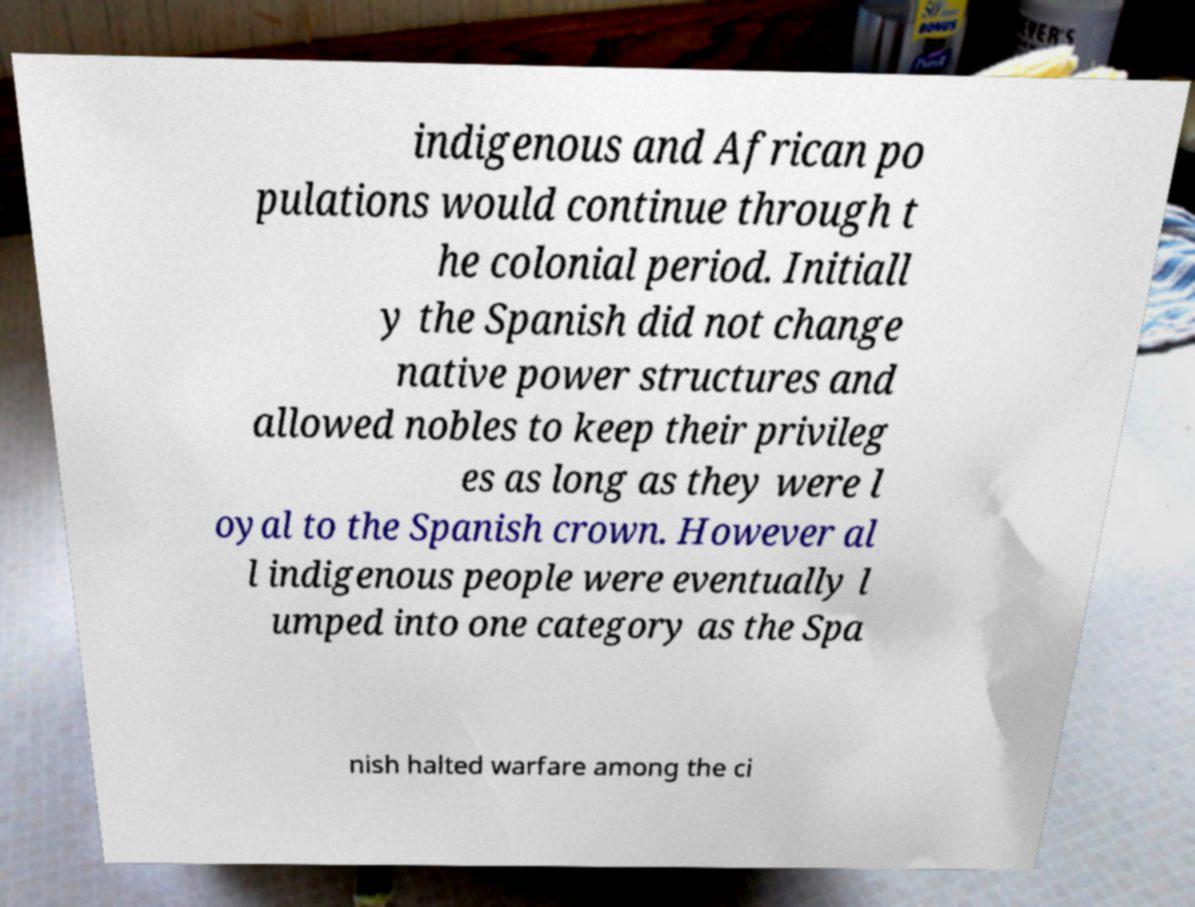For documentation purposes, I need the text within this image transcribed. Could you provide that? indigenous and African po pulations would continue through t he colonial period. Initiall y the Spanish did not change native power structures and allowed nobles to keep their privileg es as long as they were l oyal to the Spanish crown. However al l indigenous people were eventually l umped into one category as the Spa nish halted warfare among the ci 